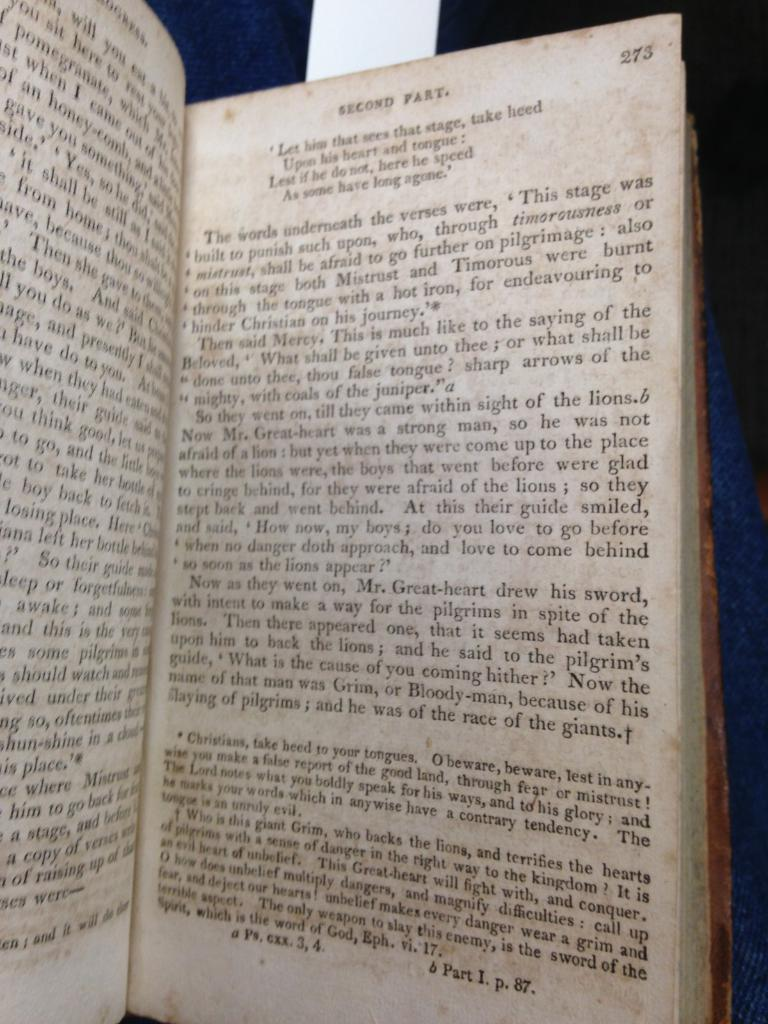<image>
Offer a succinct explanation of the picture presented. An older book open to page 273 with the header SECOND PART. 